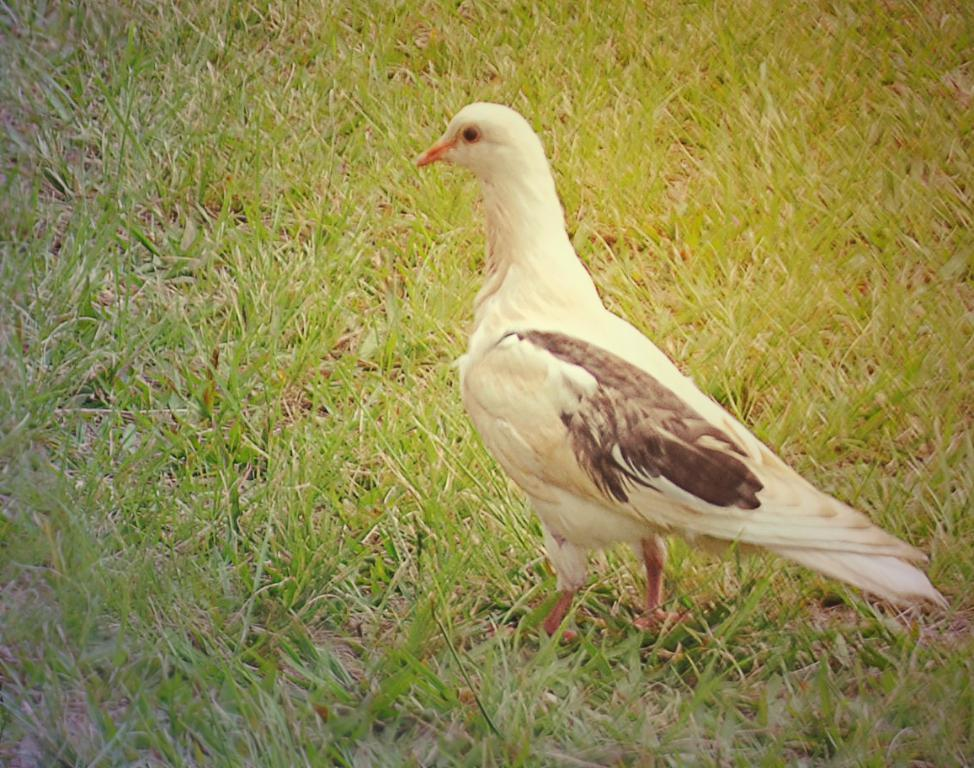What type of animal can be seen in the image? There is a bird in the image. Where is the bird located? The bird is on the grass. What type of pipe is the bird using to express its anger in the image? There is no pipe or expression of anger present in the image; it simply features a bird on the grass. 